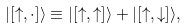<formula> <loc_0><loc_0><loc_500><loc_500>| [ \uparrow , \cdot ] \rangle \equiv | [ \uparrow , \uparrow ] \rangle + | [ \uparrow , \downarrow ] \rangle ,</formula> 